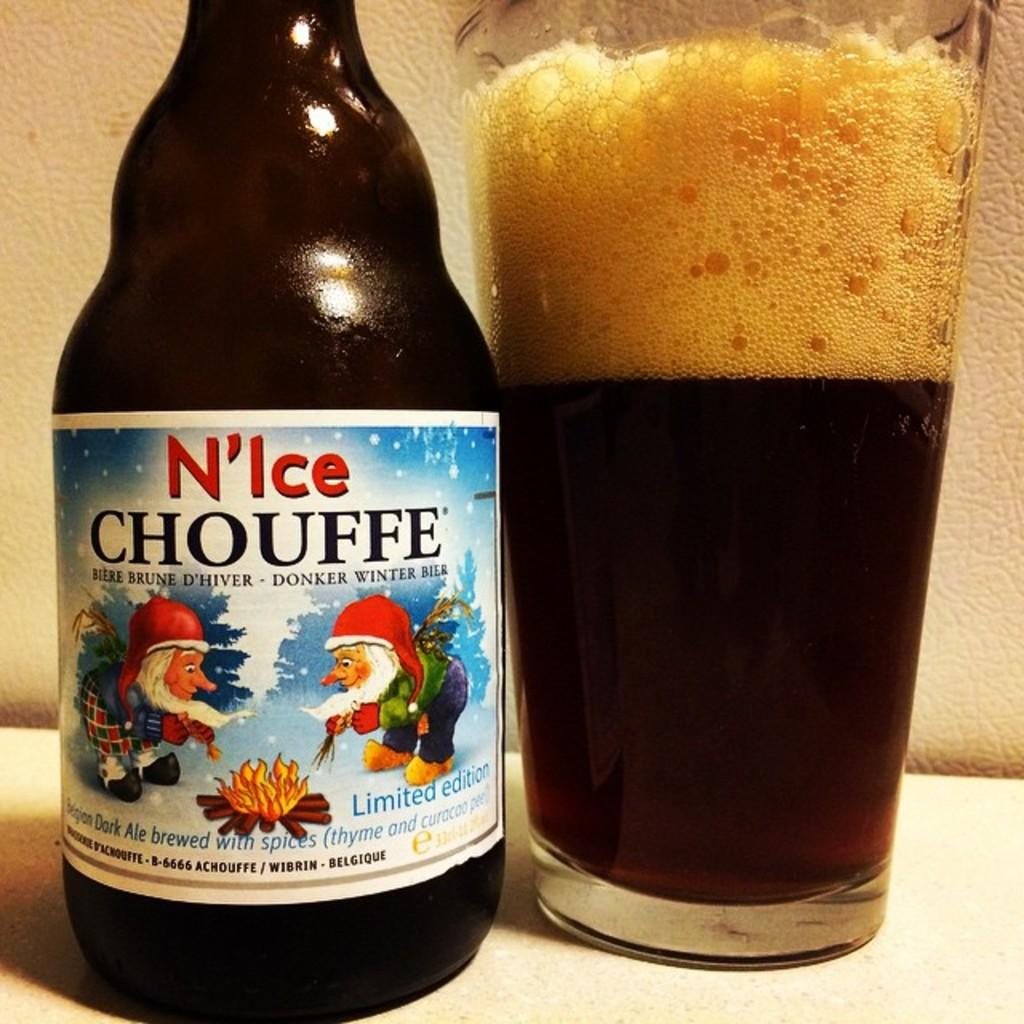What type of beverage is present in the image? There is beer in the image, both in a bottle and in a glass. What is the color of the surface the beer bottle and glass are on? The surface is white in color. How many beer-related items can be seen in the image? There are two beer-related items in the image: a beer bottle and a glass with beer in it. What type of stocking is visible on the beer bottle in the image? There is no stocking present on the beer bottle in the image. 